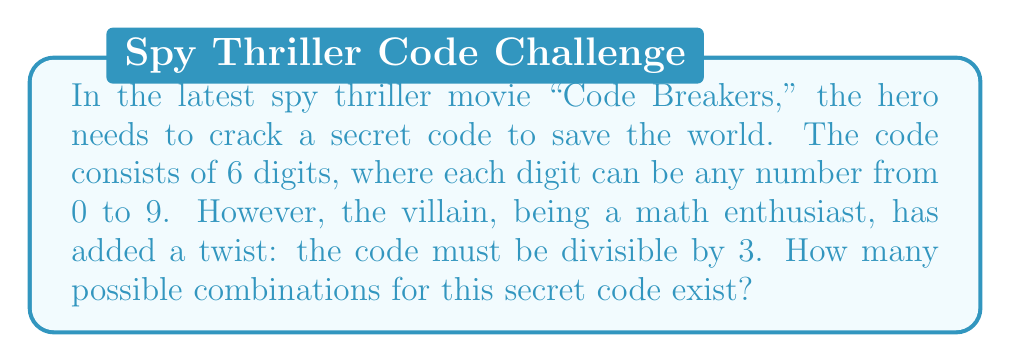Show me your answer to this math problem. Let's approach this step-by-step:

1) First, recall that a number is divisible by 3 if the sum of its digits is divisible by 3.

2) Without the divisibility constraint, we would have $10^6 = 1,000,000$ possible combinations (10 choices for each of the 6 digits).

3) To count the combinations divisible by 3, we can use the concept of modular arithmetic:
   Let $S$ be the sum of the digits. We want $S \equiv 0 \pmod{3}$.

4) There are three possibilities for $S \pmod{3}$: 0, 1, or 2.
   We want to count when $S \equiv 0 \pmod{3}$.

5) For a 6-digit number, each digit contributes to $S \pmod{3}$ as follows:
   - 0, 3, 6, 9 contribute 0
   - 1, 4, 7 contribute 1
   - 2, 5, 8 contribute 2

6) Let's count how many digits contribute each remainder:
   - 4 digits contribute 0
   - 3 digits contribute 1
   - 3 digits contribute 2

7) Now, we can use the stars and bars method to count the number of ways to choose digits such that $S \equiv 0 \pmod{3}$.

8) We need to choose 6 digits such that:
   $a + b + c \equiv 0 \pmod{3}$, where
   $a$ is the number of digits contributing 0,
   $b$ is the number of digits contributing 1,
   $c$ is the number of digits contributing 2.

9) The possible combinations for $(a,b,c)$ are:
   (6,0,0), (3,3,0), (3,0,3), (0,3,3), (4,1,1), (2,2,2)

10) For each combination, we calculate the number of ways to choose the digits:
    - (6,0,0): $\binom{6}{6}\binom{4}{6} = 4^6 = 4096$
    - (3,3,0): $\binom{6}{3}\binom{4}{3}\binom{3}{3} = 20 \cdot 64 \cdot 1 = 1280$
    - (3,0,3): $\binom{6}{3}\binom{4}{3}\binom{3}{3} = 20 \cdot 64 \cdot 1 = 1280$
    - (0,3,3): $\binom{6}{3}\binom{3}{3}\binom{3}{3} = 20 \cdot 1 \cdot 1 = 20$
    - (4,1,1): $\binom{6}{4}\binom{2}{1}\binom{4}{4}\binom{3}{1}\binom{3}{1} = 15 \cdot 2 \cdot 1 \cdot 3 \cdot 3 = 270$
    - (2,2,2): $\binom{6}{2}\binom{4}{2}\binom{4}{2}\binom{3}{2}\binom{3}{2} = 15 \cdot 6 \cdot 6 \cdot 3 \cdot 3 = 4860$

11) The total number of combinations is the sum of all these:
    4096 + 1280 + 1280 + 20 + 270 + 4860 = 11,806
Answer: There are 11,806 possible combinations for the secret code. 